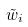<formula> <loc_0><loc_0><loc_500><loc_500>\tilde { w } _ { i }</formula> 